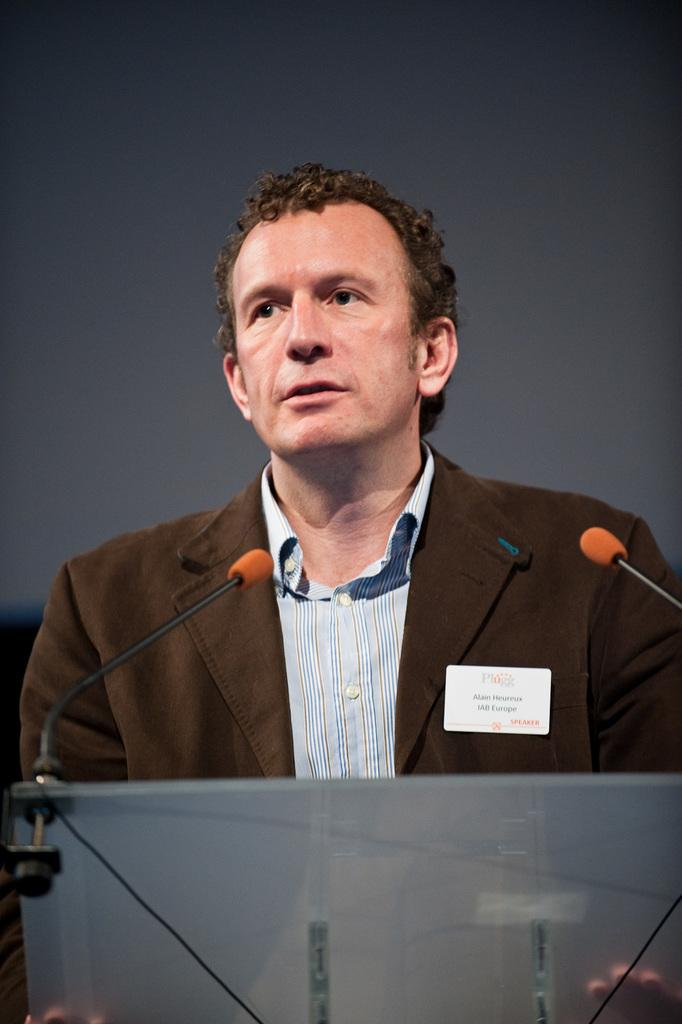What can be seen in the image? There is a person in the image. What is the person wearing? The person is wearing a brown suit. What is the person doing in the image? The person is speaking. What object is present in the image that is related to the person speaking? There is a microphone in the image, which is placed on a stand. Where is the microphone positioned in relation to the person? The microphone is in front of the person. What type of glass can be seen on the table next to the person? There is no glass present on the table next to the person in the image. What kind of breakfast is the person eating while speaking? There is no breakfast visible in the image; the person is only speaking. 